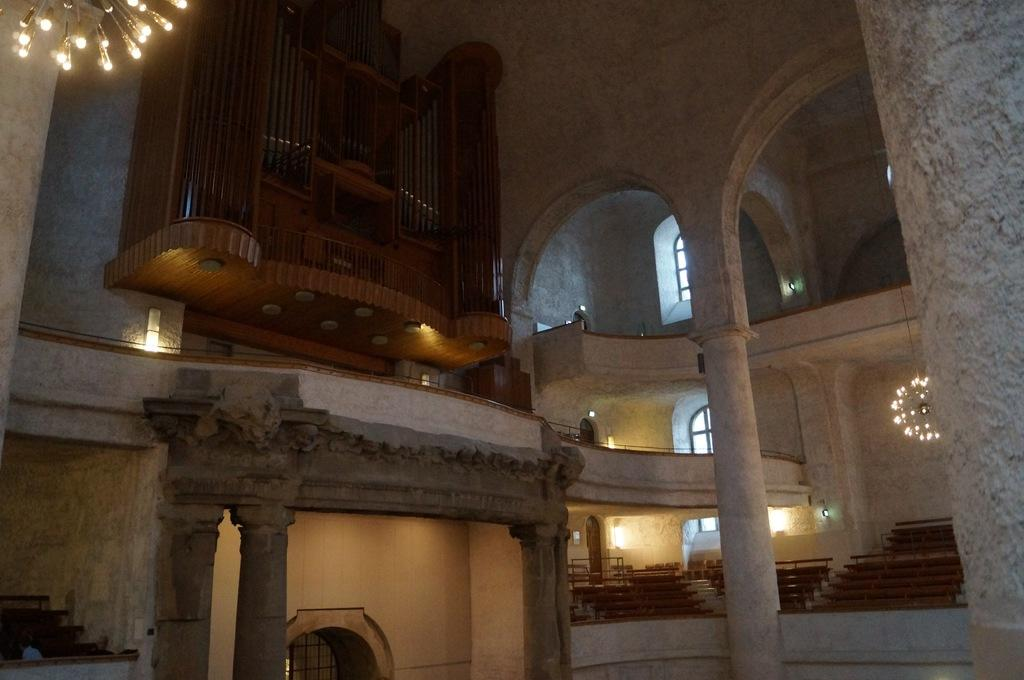What type of location is depicted in the image? The image shows an inside view of a building. What can be seen in the building that provides illumination? There are lights in the building. What architectural feature allows for movement between different levels in the building? There are steps in the building. What structural elements support the building's weight? There are pillars in the building. What is attached to the wall in the image? There is a wooden object on the wall. How can natural light enter the building? There are windows in the building. How can people enter or exit the building? There are doors in the building. What type of punishment is being administered in the building in the image? There is no indication of punishment being administered in the image; it shows an inside view of a building with various architectural features. 